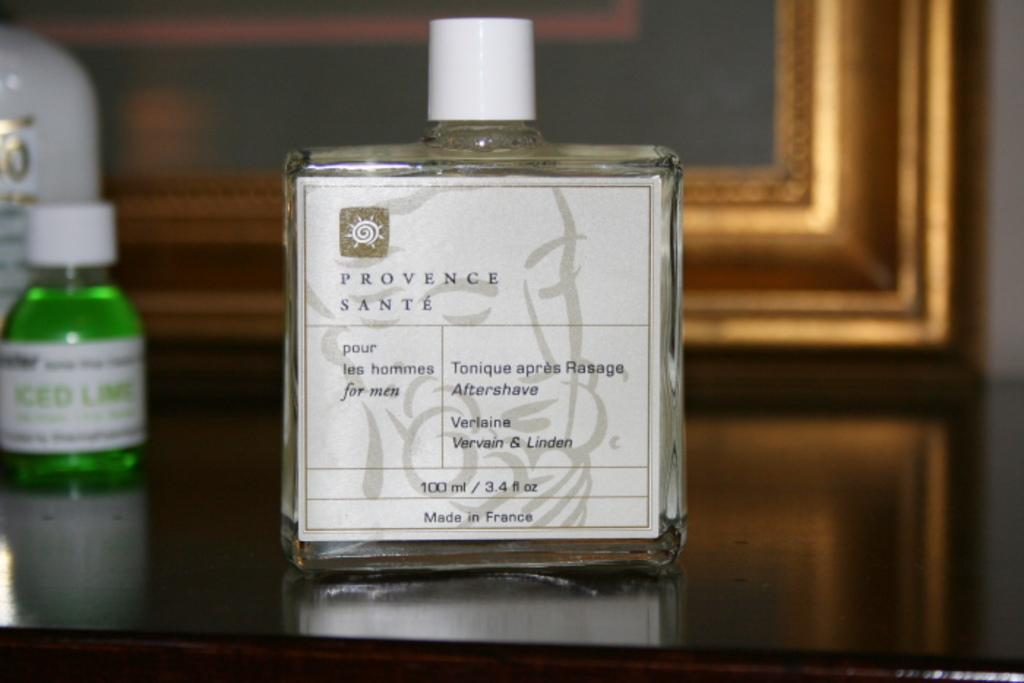<image>
Render a clear and concise summary of the photo. A small bottle of Provence Sante perfume sitting on a table. 